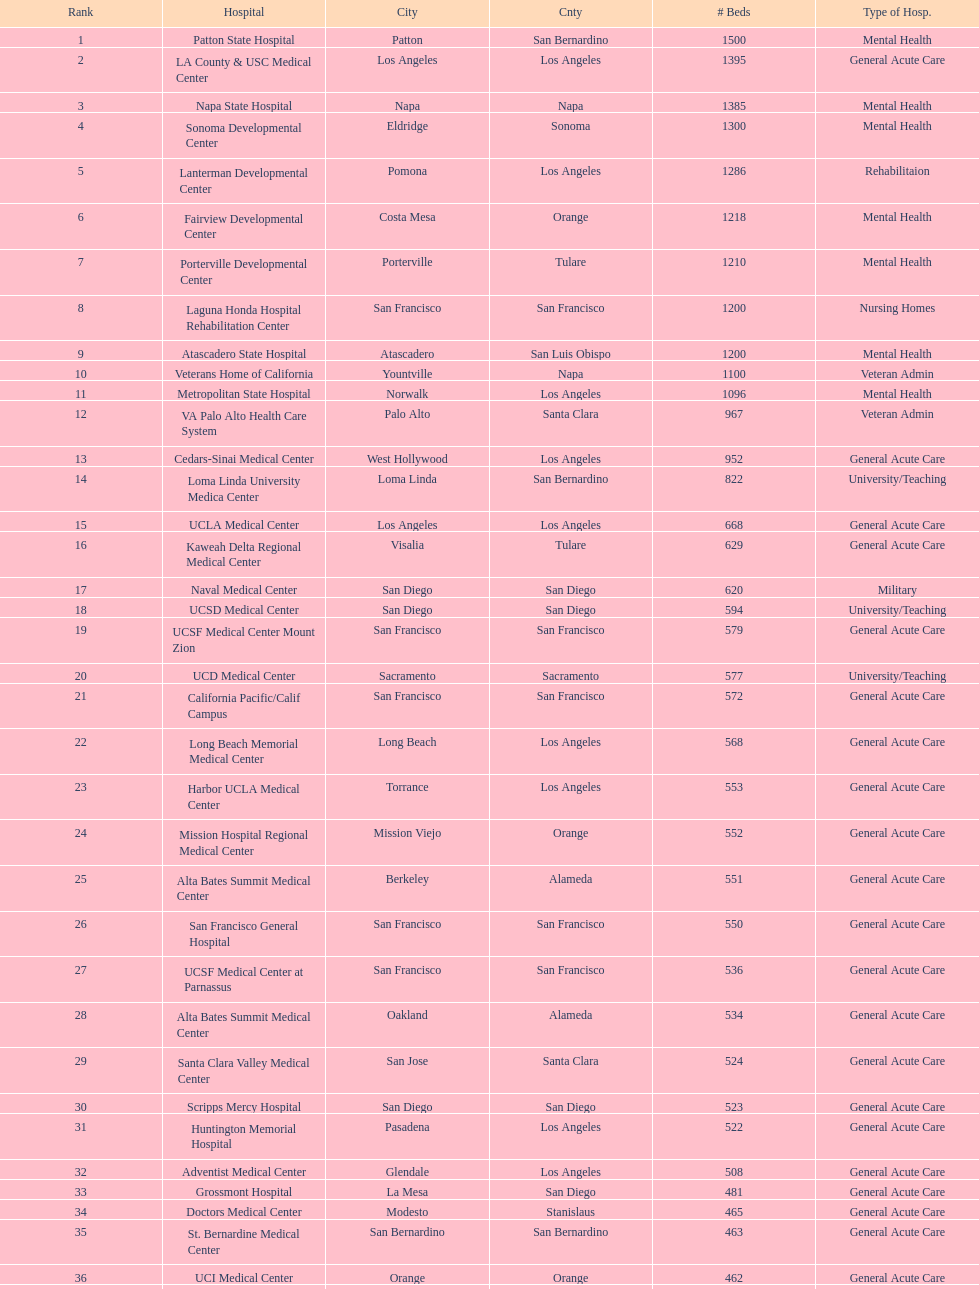What two hospitals holding consecutive rankings of 8 and 9 respectively, both provide 1200 hospital beds? Laguna Honda Hospital Rehabilitation Center, Atascadero State Hospital. Would you mind parsing the complete table? {'header': ['Rank', 'Hospital', 'City', 'Cnty', '# Beds', 'Type of Hosp.'], 'rows': [['1', 'Patton State Hospital', 'Patton', 'San Bernardino', '1500', 'Mental Health'], ['2', 'LA County & USC Medical Center', 'Los Angeles', 'Los Angeles', '1395', 'General Acute Care'], ['3', 'Napa State Hospital', 'Napa', 'Napa', '1385', 'Mental Health'], ['4', 'Sonoma Developmental Center', 'Eldridge', 'Sonoma', '1300', 'Mental Health'], ['5', 'Lanterman Developmental Center', 'Pomona', 'Los Angeles', '1286', 'Rehabilitaion'], ['6', 'Fairview Developmental Center', 'Costa Mesa', 'Orange', '1218', 'Mental Health'], ['7', 'Porterville Developmental Center', 'Porterville', 'Tulare', '1210', 'Mental Health'], ['8', 'Laguna Honda Hospital Rehabilitation Center', 'San Francisco', 'San Francisco', '1200', 'Nursing Homes'], ['9', 'Atascadero State Hospital', 'Atascadero', 'San Luis Obispo', '1200', 'Mental Health'], ['10', 'Veterans Home of California', 'Yountville', 'Napa', '1100', 'Veteran Admin'], ['11', 'Metropolitan State Hospital', 'Norwalk', 'Los Angeles', '1096', 'Mental Health'], ['12', 'VA Palo Alto Health Care System', 'Palo Alto', 'Santa Clara', '967', 'Veteran Admin'], ['13', 'Cedars-Sinai Medical Center', 'West Hollywood', 'Los Angeles', '952', 'General Acute Care'], ['14', 'Loma Linda University Medica Center', 'Loma Linda', 'San Bernardino', '822', 'University/Teaching'], ['15', 'UCLA Medical Center', 'Los Angeles', 'Los Angeles', '668', 'General Acute Care'], ['16', 'Kaweah Delta Regional Medical Center', 'Visalia', 'Tulare', '629', 'General Acute Care'], ['17', 'Naval Medical Center', 'San Diego', 'San Diego', '620', 'Military'], ['18', 'UCSD Medical Center', 'San Diego', 'San Diego', '594', 'University/Teaching'], ['19', 'UCSF Medical Center Mount Zion', 'San Francisco', 'San Francisco', '579', 'General Acute Care'], ['20', 'UCD Medical Center', 'Sacramento', 'Sacramento', '577', 'University/Teaching'], ['21', 'California Pacific/Calif Campus', 'San Francisco', 'San Francisco', '572', 'General Acute Care'], ['22', 'Long Beach Memorial Medical Center', 'Long Beach', 'Los Angeles', '568', 'General Acute Care'], ['23', 'Harbor UCLA Medical Center', 'Torrance', 'Los Angeles', '553', 'General Acute Care'], ['24', 'Mission Hospital Regional Medical Center', 'Mission Viejo', 'Orange', '552', 'General Acute Care'], ['25', 'Alta Bates Summit Medical Center', 'Berkeley', 'Alameda', '551', 'General Acute Care'], ['26', 'San Francisco General Hospital', 'San Francisco', 'San Francisco', '550', 'General Acute Care'], ['27', 'UCSF Medical Center at Parnassus', 'San Francisco', 'San Francisco', '536', 'General Acute Care'], ['28', 'Alta Bates Summit Medical Center', 'Oakland', 'Alameda', '534', 'General Acute Care'], ['29', 'Santa Clara Valley Medical Center', 'San Jose', 'Santa Clara', '524', 'General Acute Care'], ['30', 'Scripps Mercy Hospital', 'San Diego', 'San Diego', '523', 'General Acute Care'], ['31', 'Huntington Memorial Hospital', 'Pasadena', 'Los Angeles', '522', 'General Acute Care'], ['32', 'Adventist Medical Center', 'Glendale', 'Los Angeles', '508', 'General Acute Care'], ['33', 'Grossmont Hospital', 'La Mesa', 'San Diego', '481', 'General Acute Care'], ['34', 'Doctors Medical Center', 'Modesto', 'Stanislaus', '465', 'General Acute Care'], ['35', 'St. Bernardine Medical Center', 'San Bernardino', 'San Bernardino', '463', 'General Acute Care'], ['36', 'UCI Medical Center', 'Orange', 'Orange', '462', 'General Acute Care'], ['37', 'Stanford Medical Center', 'Stanford', 'Santa Clara', '460', 'General Acute Care'], ['38', 'Community Regional Medical Center', 'Fresno', 'Fresno', '457', 'General Acute Care'], ['39', 'Methodist Hospital', 'Arcadia', 'Los Angeles', '455', 'General Acute Care'], ['40', 'Providence St. Joseph Medical Center', 'Burbank', 'Los Angeles', '455', 'General Acute Care'], ['41', 'Hoag Memorial Hospital', 'Newport Beach', 'Orange', '450', 'General Acute Care'], ['42', 'Agnews Developmental Center', 'San Jose', 'Santa Clara', '450', 'Mental Health'], ['43', 'Jewish Home', 'San Francisco', 'San Francisco', '450', 'Nursing Homes'], ['44', 'St. Joseph Hospital Orange', 'Orange', 'Orange', '448', 'General Acute Care'], ['45', 'Presbyterian Intercommunity', 'Whittier', 'Los Angeles', '441', 'General Acute Care'], ['46', 'Kaiser Permanente Medical Center', 'Fontana', 'San Bernardino', '440', 'General Acute Care'], ['47', 'Kaiser Permanente Medical Center', 'Los Angeles', 'Los Angeles', '439', 'General Acute Care'], ['48', 'Pomona Valley Hospital Medical Center', 'Pomona', 'Los Angeles', '436', 'General Acute Care'], ['49', 'Sutter General Medical Center', 'Sacramento', 'Sacramento', '432', 'General Acute Care'], ['50', 'St. Mary Medical Center', 'San Francisco', 'San Francisco', '430', 'General Acute Care'], ['50', 'Good Samaritan Hospital', 'San Jose', 'Santa Clara', '429', 'General Acute Care']]} 